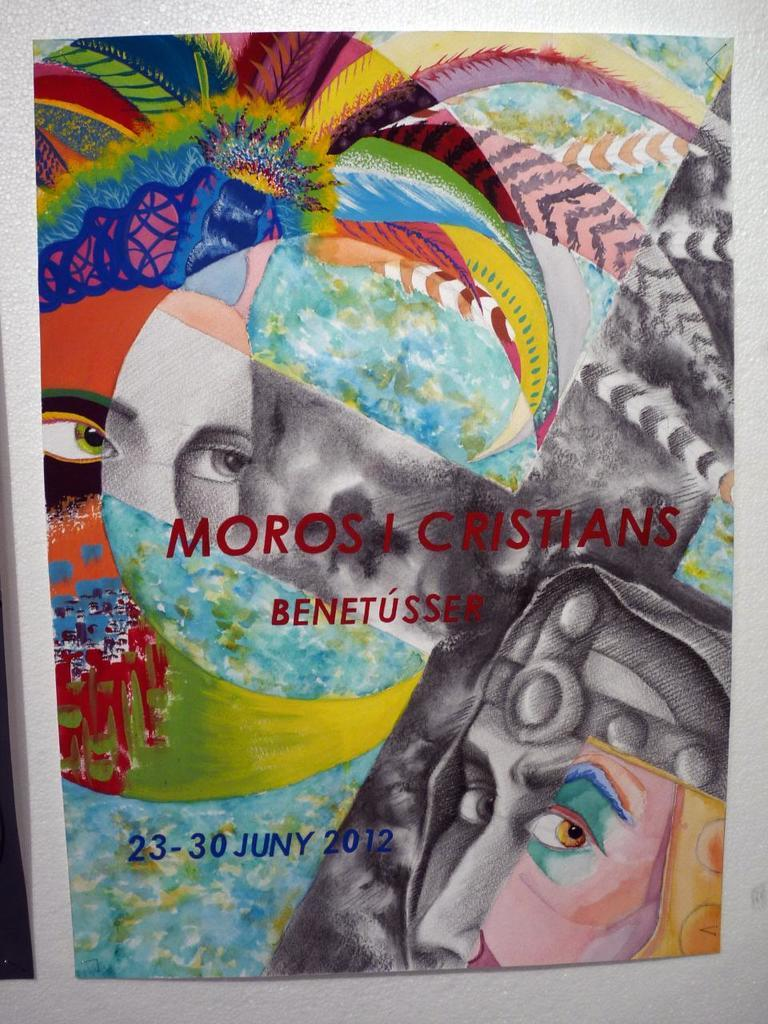What is present in the image that features text or graphics? There is a poster in the image. What can be found on the poster besides its design or graphics? There is writing on the poster. Who or what can be seen on the poster? There are people depicted on the poster. Where are the scissorssissors located in the image? There are no scissors present in the image. What type of society is depicted on the poster? The image does not depict a society; it only shows a poster with writing and people on it. Can you see a giraffe in the image? There is no giraffe present in the image. 